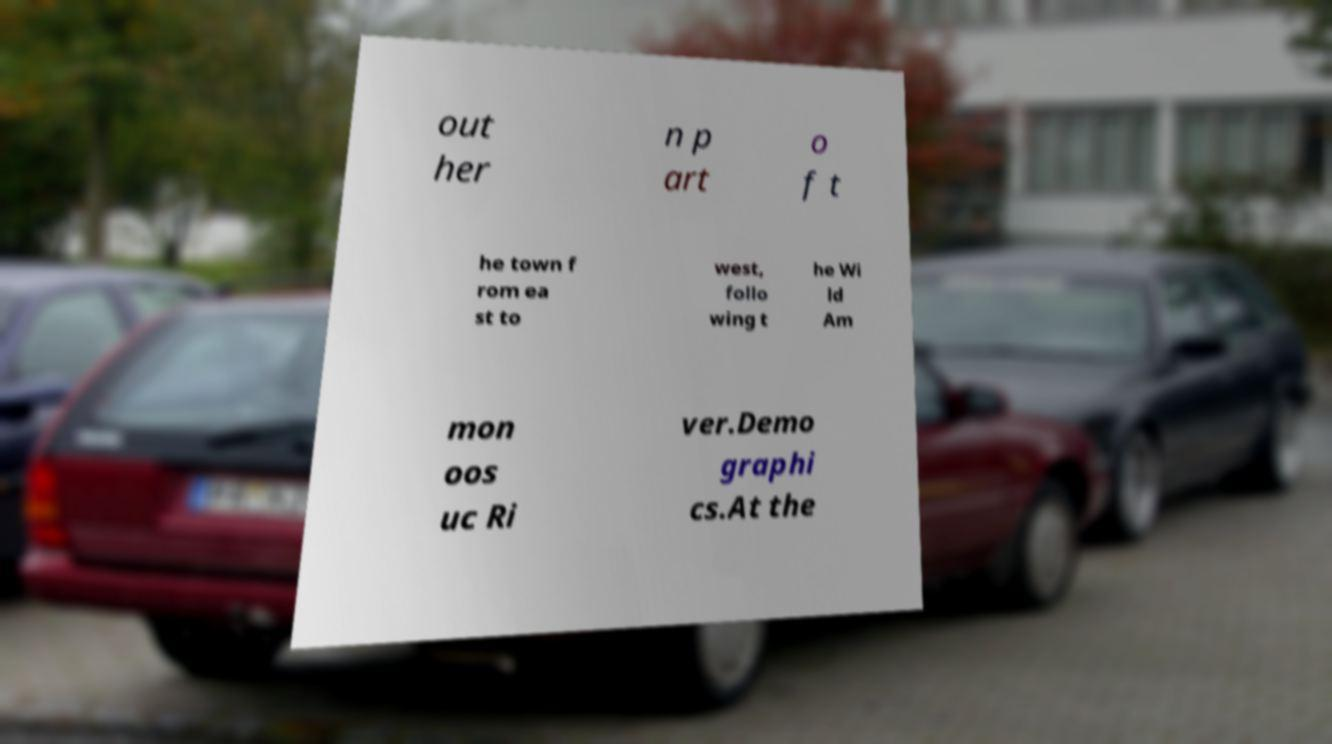Please read and relay the text visible in this image. What does it say? out her n p art o f t he town f rom ea st to west, follo wing t he Wi ld Am mon oos uc Ri ver.Demo graphi cs.At the 